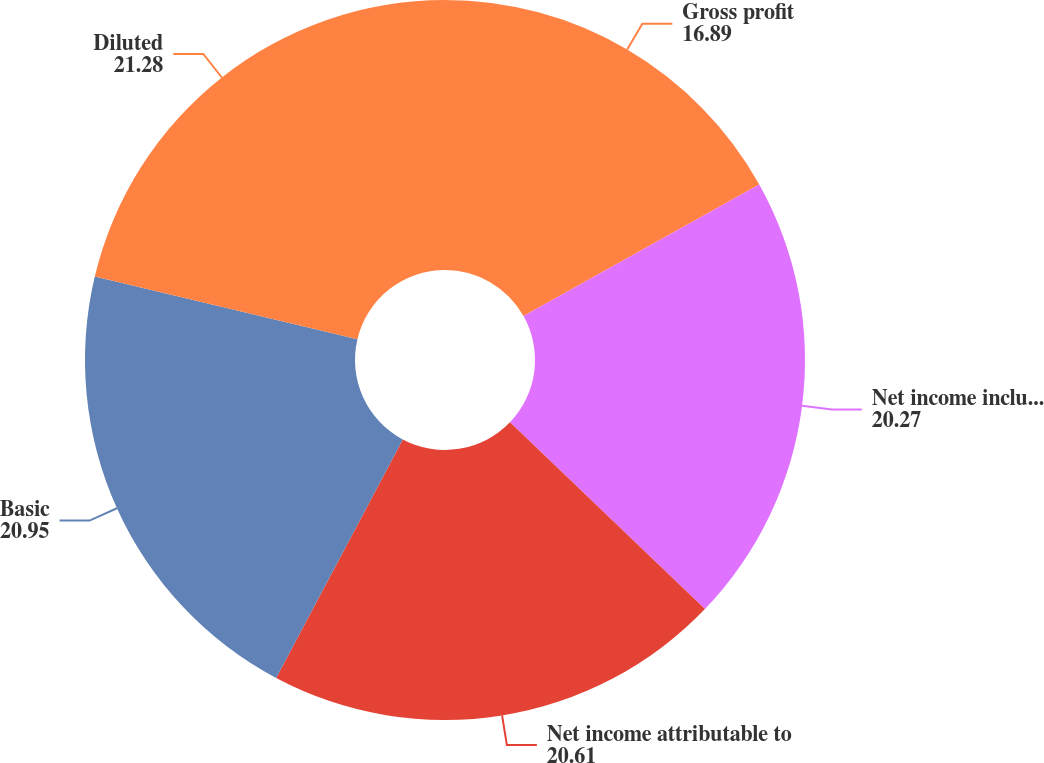Convert chart to OTSL. <chart><loc_0><loc_0><loc_500><loc_500><pie_chart><fcel>Gross profit<fcel>Net income including<fcel>Net income attributable to<fcel>Basic<fcel>Diluted<nl><fcel>16.89%<fcel>20.27%<fcel>20.61%<fcel>20.95%<fcel>21.28%<nl></chart> 